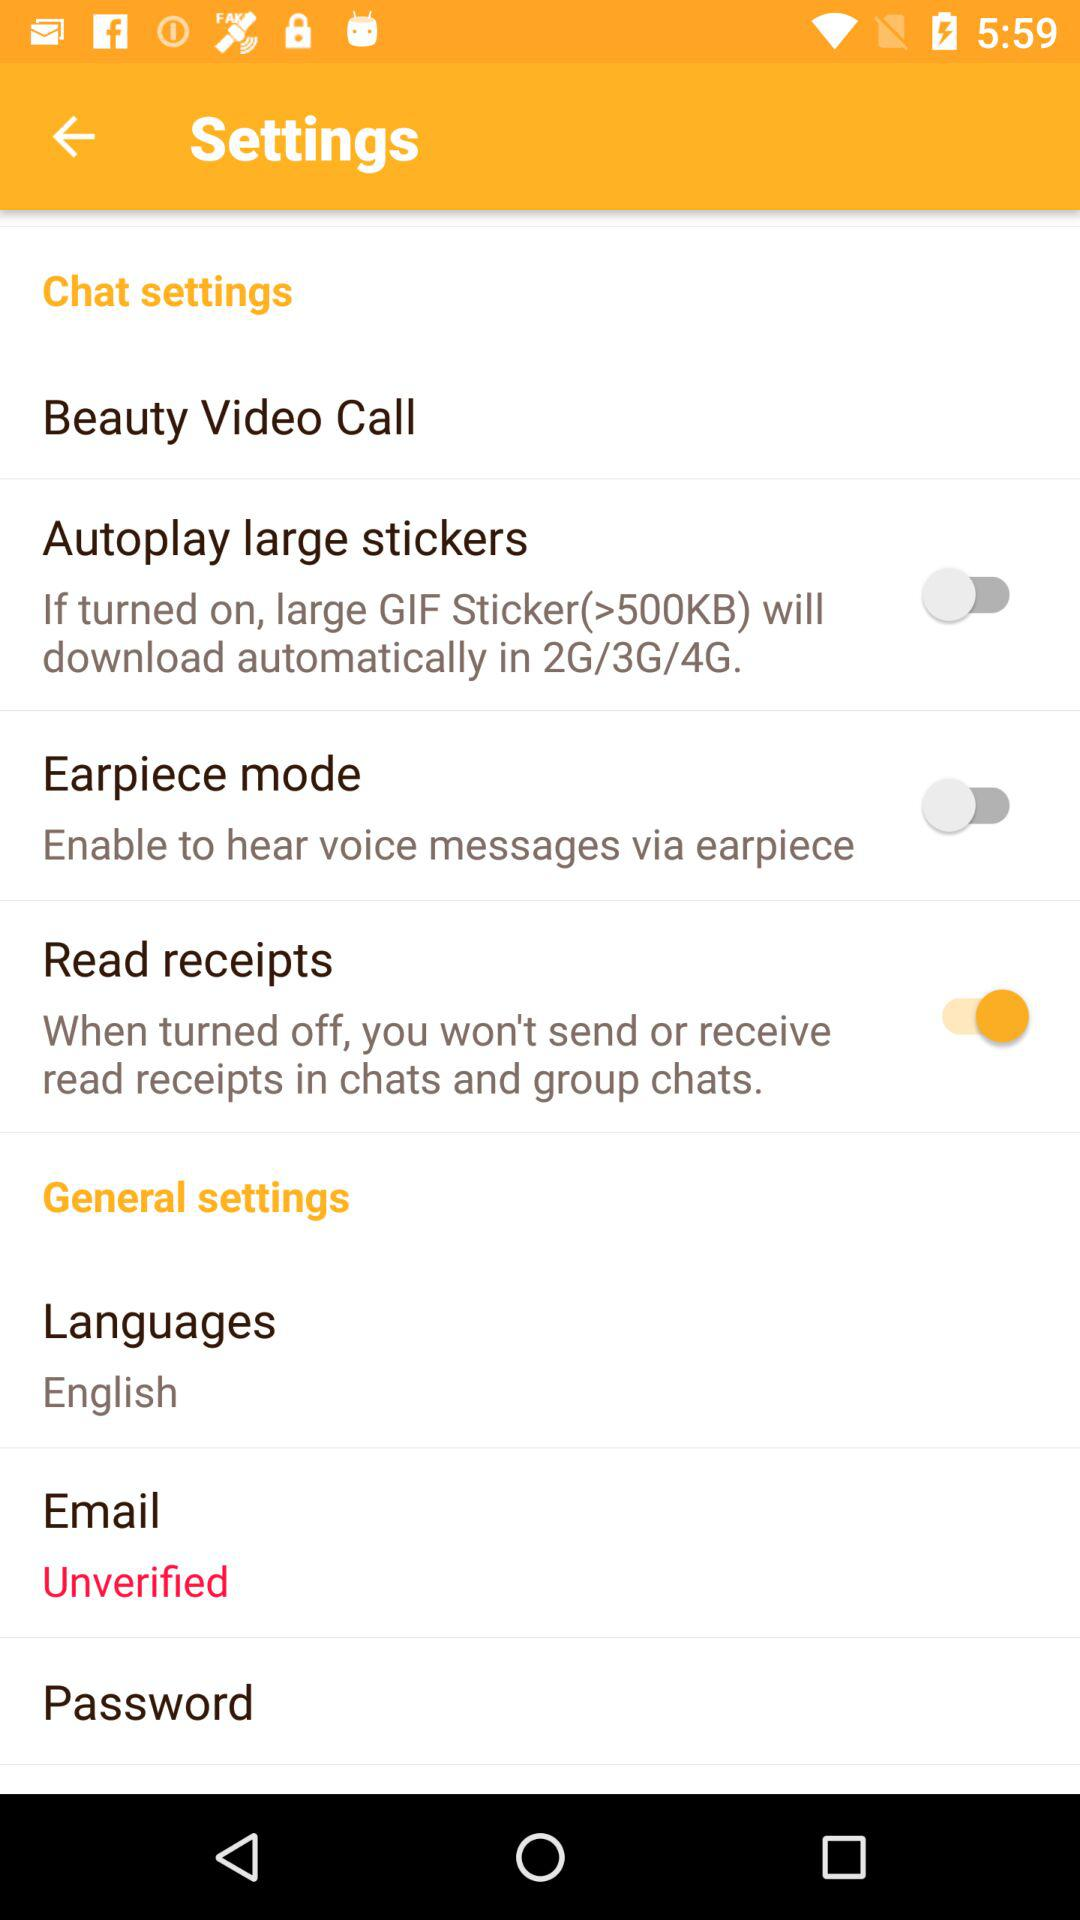What is the status of the "Read receipts"? The status is "on". 